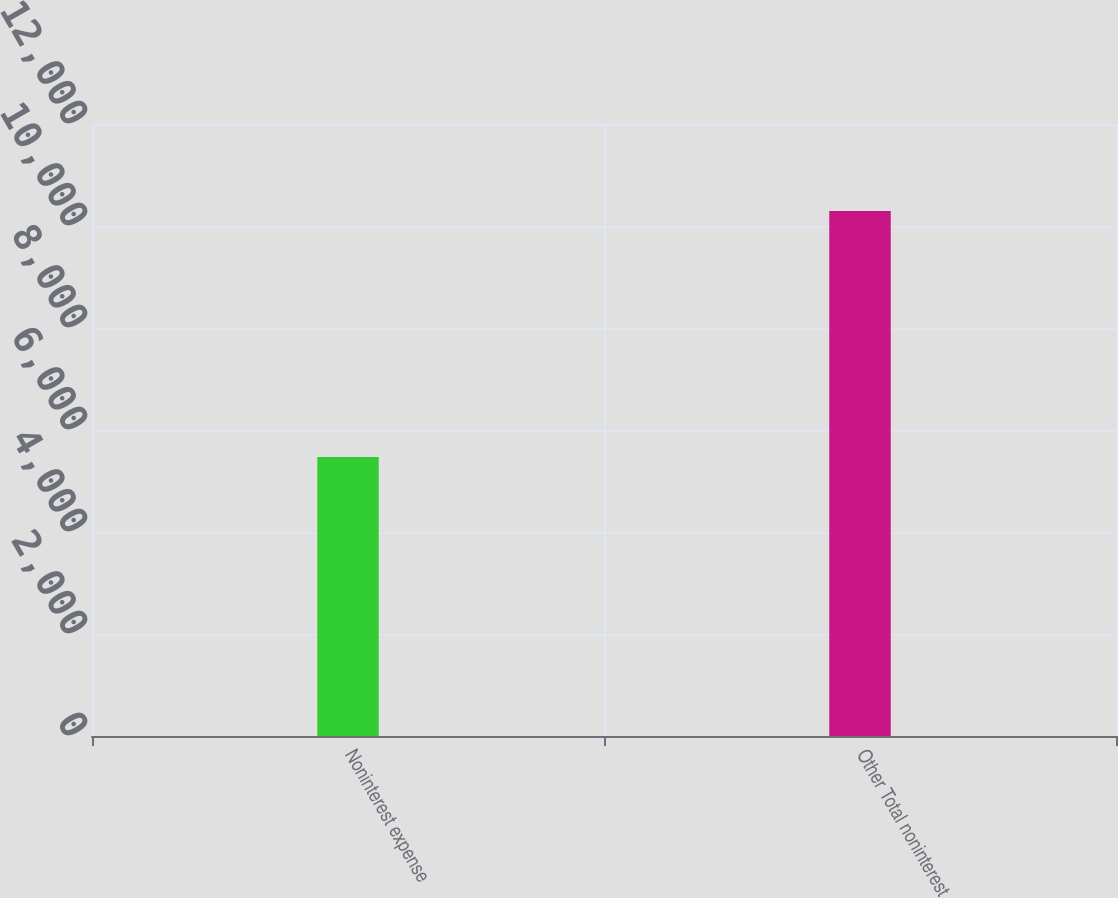Convert chart to OTSL. <chart><loc_0><loc_0><loc_500><loc_500><bar_chart><fcel>Noninterest expense<fcel>Other Total noninterest<nl><fcel>5471<fcel>10296<nl></chart> 